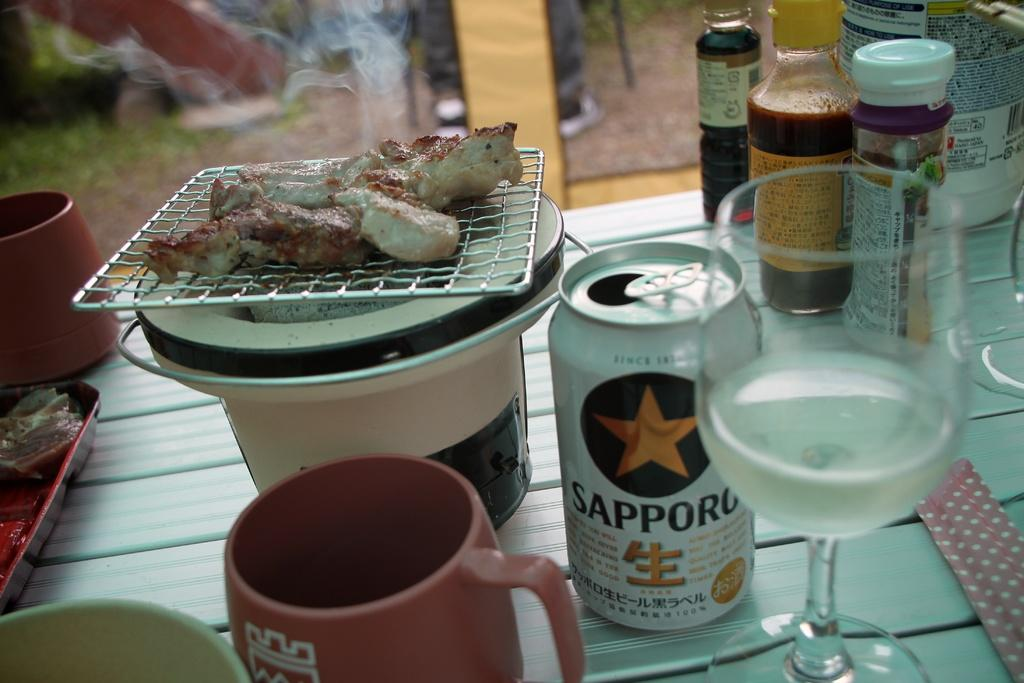<image>
Write a terse but informative summary of the picture. A can of Sapporo sitting next to a small grill with meat on it. 